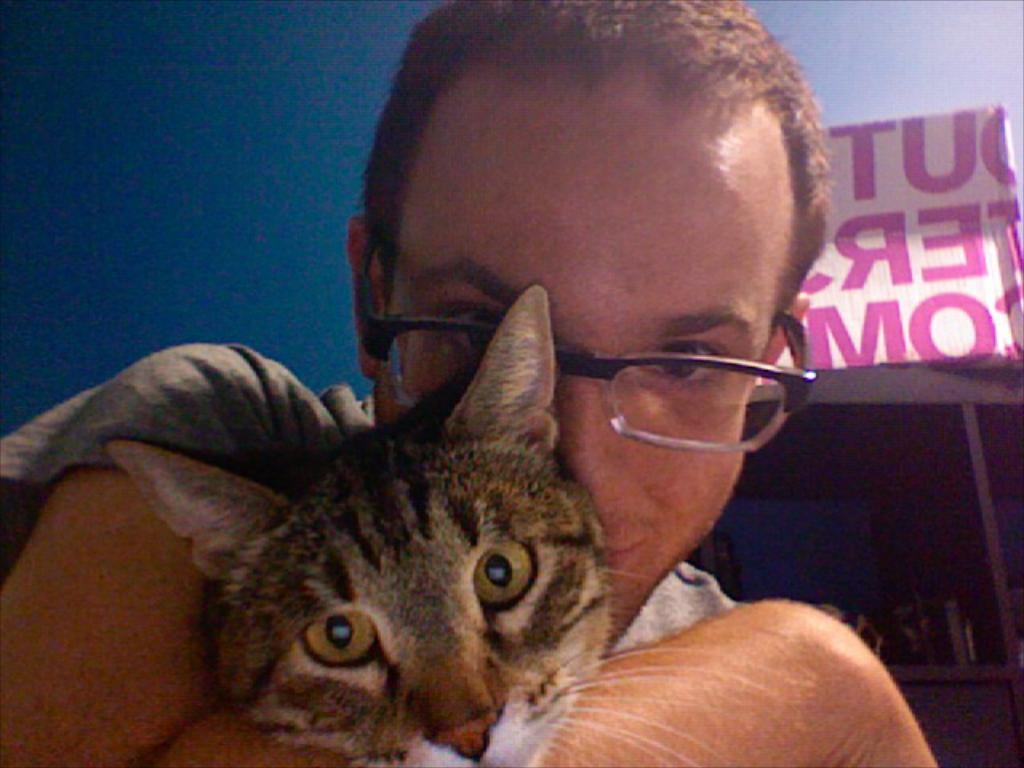What is the main subject of the image? There is a man in the image. Are there any animals present in the image? Yes, there is a cat in the image. What can be observed about the man's appearance? The man is wearing glasses (specs) in the image. How many times has the man folded the cat in the image? There is no indication in the image that the man has folded the cat, as cats do not fold like paper or fabric. 